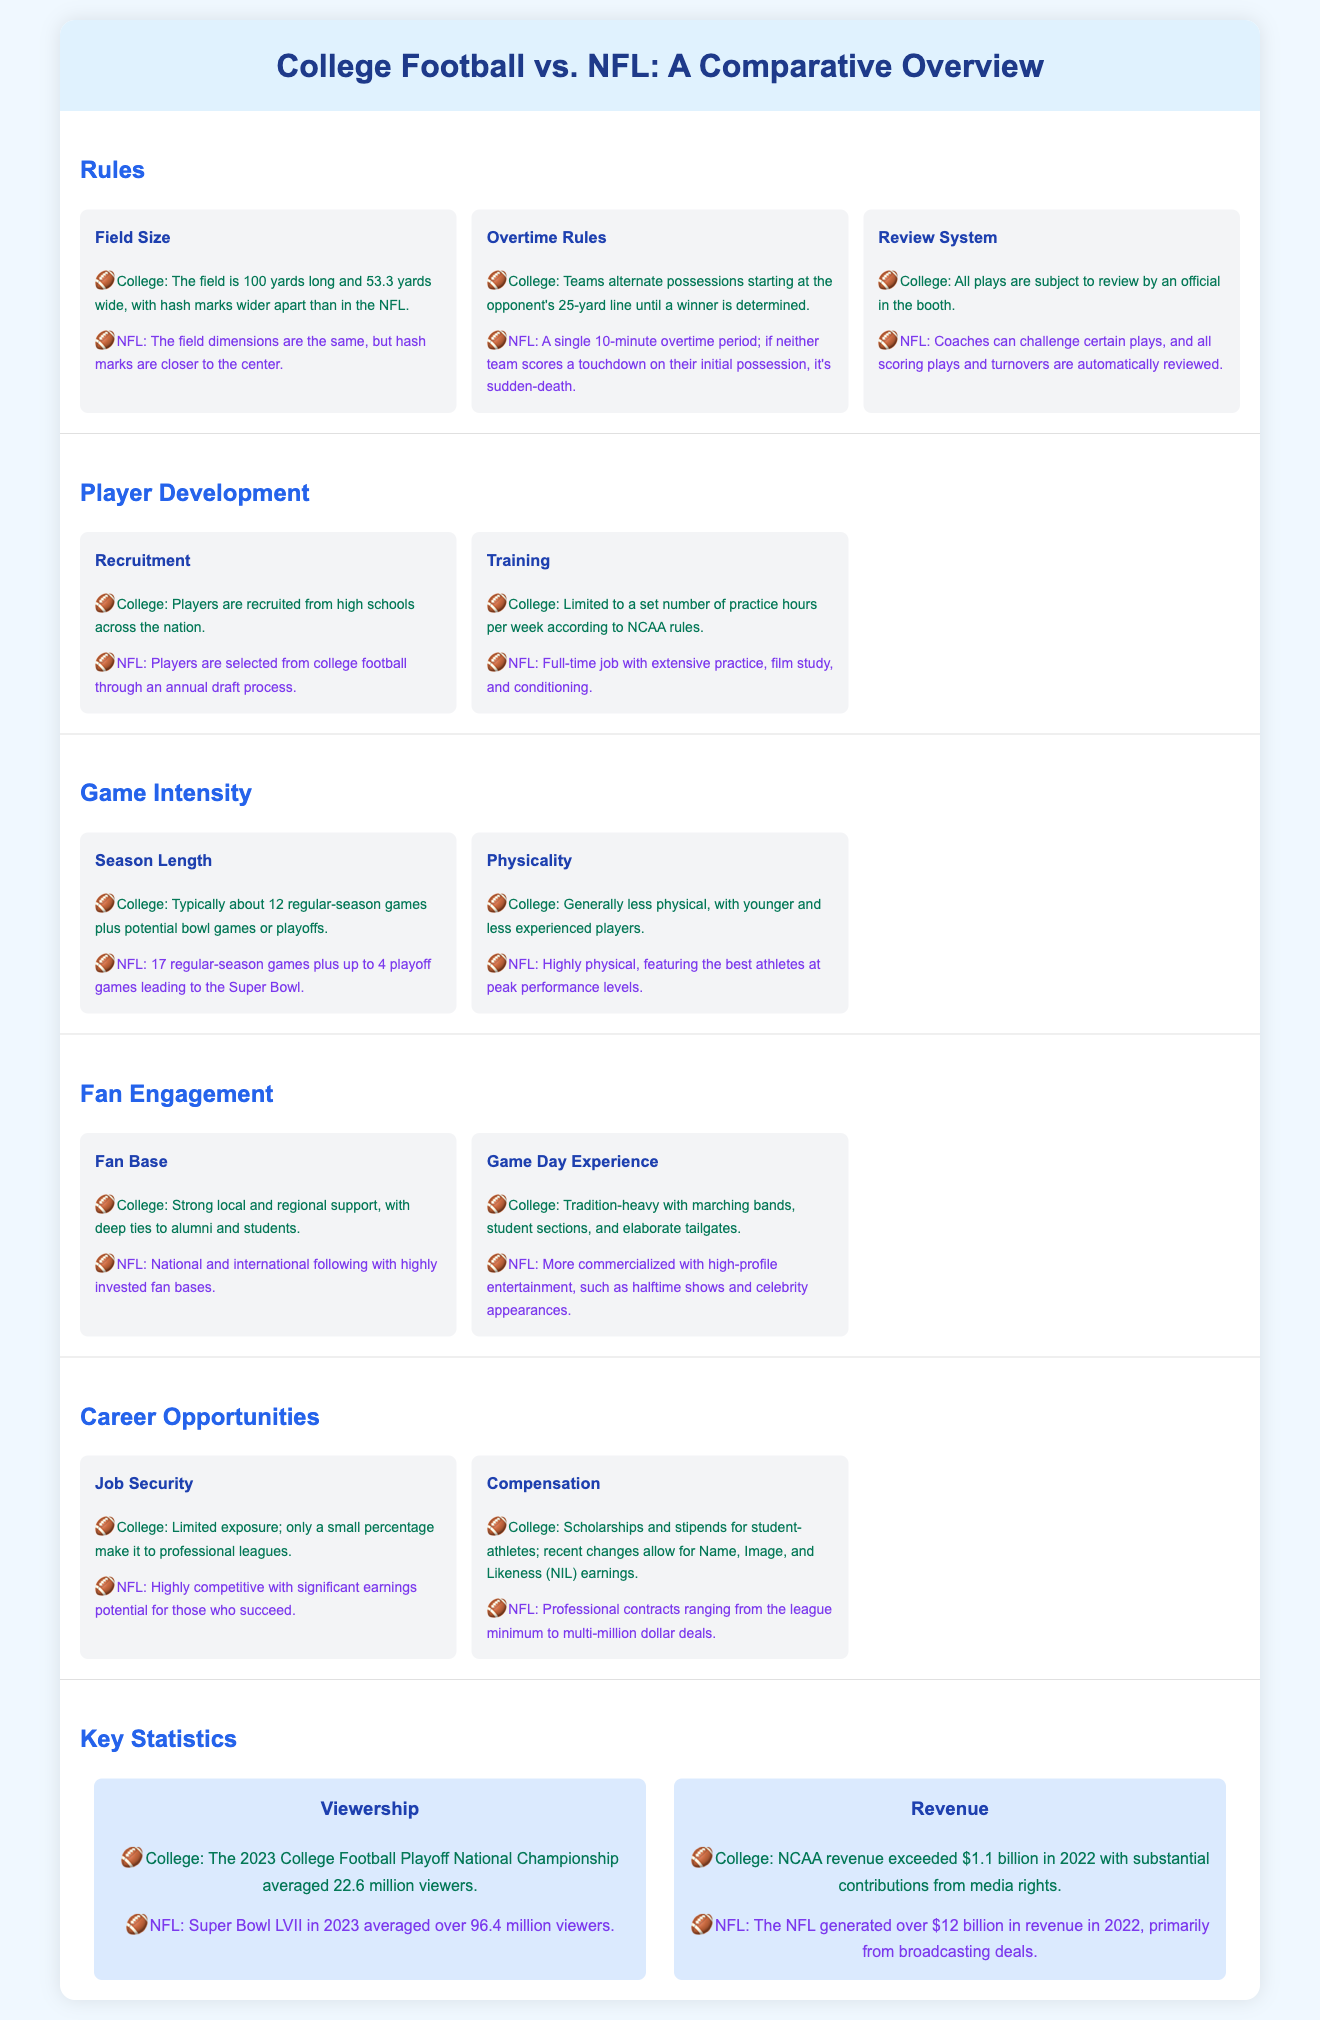what is the regular-season game length in the NFL? The NFL regular-season consists of 17 games, as stated in the Game Intensity section.
Answer: 17 what promotional activities are found on game days in the NFL? The Game Day Experience for the NFL mentions high-profile entertainment like halftime shows and celebrity appearances.
Answer: Entertainment what is the average viewership for the 2023 College Football Playoff National Championship? The Key Statistics section indicates the average viewership was 22.6 million.
Answer: 22.6 million how many playoff games can an NFL team play? The Game Intensity section specifies that NFL teams can play up to 4 playoff games.
Answer: 4 what do college players receive in terms of compensation? The Career Opportunities section notes that college athletes get scholarships and stipends, with recent changes allowing for NIL earnings.
Answer: Scholarships and stipends what is the primary source of revenue for the NFL? The NFL's revenue is primarily generated from broadcasting deals, as indicated in the Key Statistics section.
Answer: Broadcasting deals what are the hash marks in college football compared to the NFL? The Rules section mentions that college hash marks are wider apart than in the NFL.
Answer: Wider apart what do college players focus on in training compared to NFL players? The Player Development section states that college players have a limited number of practice hours, while NFL players have extensive training.
Answer: Limited hours which league has a stronger national following? The Fan Engagement section describes the NFL as having a national and international following.
Answer: NFL 